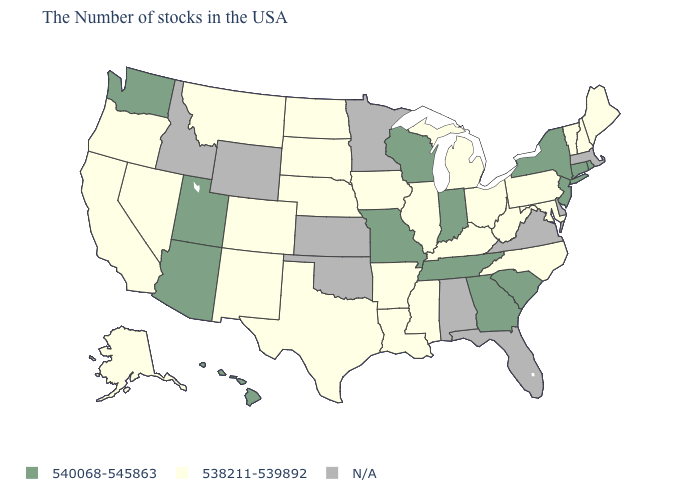What is the value of Alaska?
Answer briefly. 538211-539892. Name the states that have a value in the range 538211-539892?
Answer briefly. Maine, New Hampshire, Vermont, Maryland, Pennsylvania, North Carolina, West Virginia, Ohio, Michigan, Kentucky, Illinois, Mississippi, Louisiana, Arkansas, Iowa, Nebraska, Texas, South Dakota, North Dakota, Colorado, New Mexico, Montana, Nevada, California, Oregon, Alaska. Name the states that have a value in the range 538211-539892?
Answer briefly. Maine, New Hampshire, Vermont, Maryland, Pennsylvania, North Carolina, West Virginia, Ohio, Michigan, Kentucky, Illinois, Mississippi, Louisiana, Arkansas, Iowa, Nebraska, Texas, South Dakota, North Dakota, Colorado, New Mexico, Montana, Nevada, California, Oregon, Alaska. What is the highest value in the USA?
Answer briefly. 540068-545863. Does the map have missing data?
Answer briefly. Yes. How many symbols are there in the legend?
Keep it brief. 3. What is the lowest value in states that border Idaho?
Concise answer only. 538211-539892. What is the value of Minnesota?
Write a very short answer. N/A. Name the states that have a value in the range 538211-539892?
Write a very short answer. Maine, New Hampshire, Vermont, Maryland, Pennsylvania, North Carolina, West Virginia, Ohio, Michigan, Kentucky, Illinois, Mississippi, Louisiana, Arkansas, Iowa, Nebraska, Texas, South Dakota, North Dakota, Colorado, New Mexico, Montana, Nevada, California, Oregon, Alaska. What is the value of New Hampshire?
Answer briefly. 538211-539892. Does South Carolina have the highest value in the South?
Give a very brief answer. Yes. Name the states that have a value in the range N/A?
Be succinct. Massachusetts, Delaware, Virginia, Florida, Alabama, Minnesota, Kansas, Oklahoma, Wyoming, Idaho. What is the value of Montana?
Be succinct. 538211-539892. 